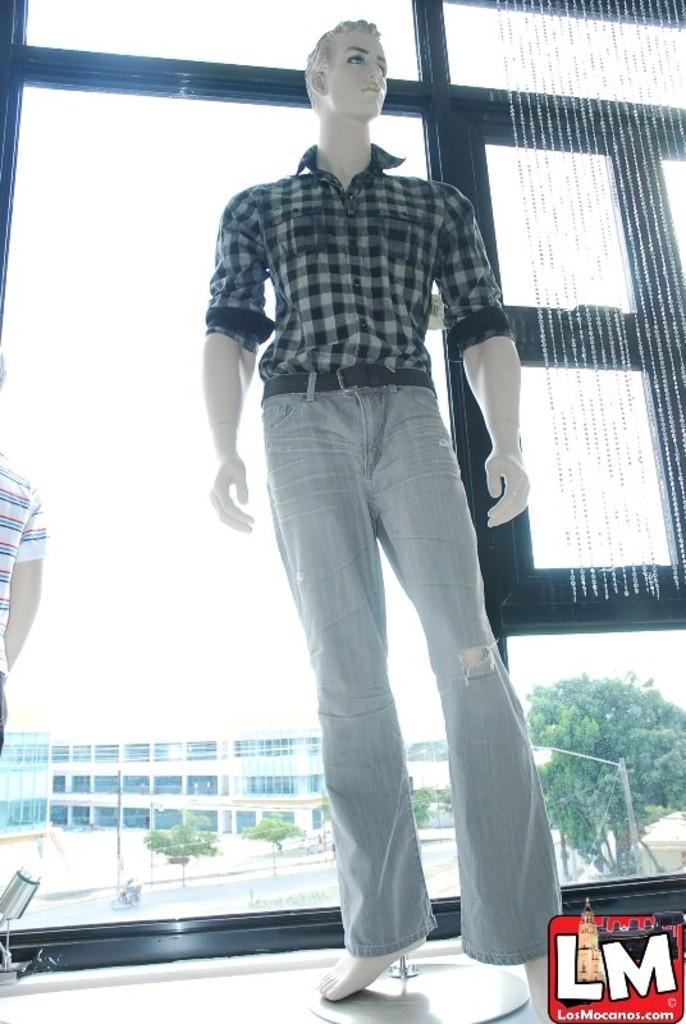Can you describe this image briefly? In this image we can see a mannequin with dress and in the background there is a building, trees and a light pole and there are decorative items hanged to the window. 